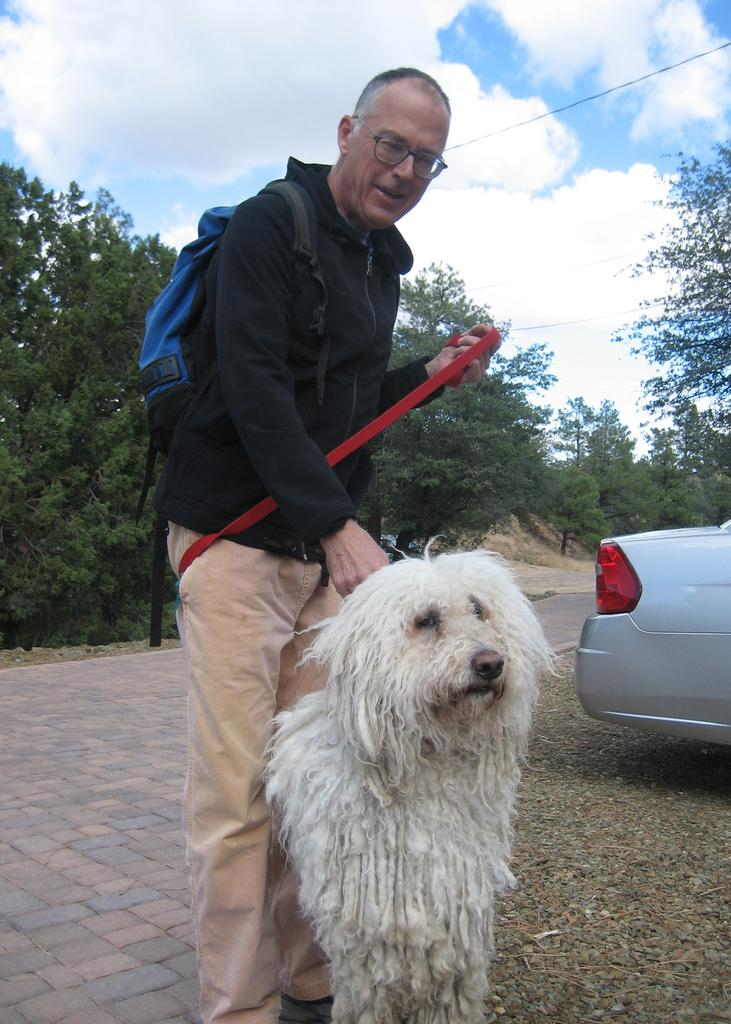What is the main subject of the image? The main subject of the image is a man. What is the man doing in the image? The man is standing and holding a dog in one hand and a thread in the other hand. What can be seen in the background of the image? There are trees, the sky, clouds, and a car in the background of the image. What type of ink is being used for the selection process in the image? There is no ink or selection process present in the image. How is the distribution of resources being managed in the image? There is no reference to resources or their distribution in the image. 